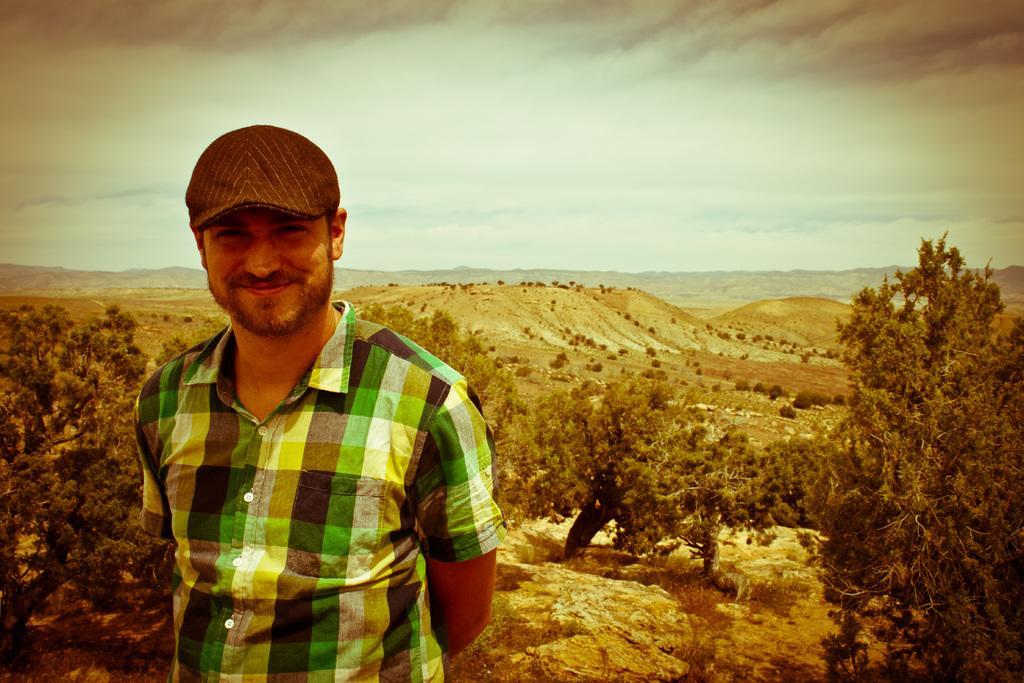Describe this image in one or two sentences. In this image there is the sky towards the top of the image, there are hills, there are plants, there are trees, there is ground towards the bottom of the image, there is a man standing towards the bottom of the image, he is wearing a shirt, he is wearing a cap. 